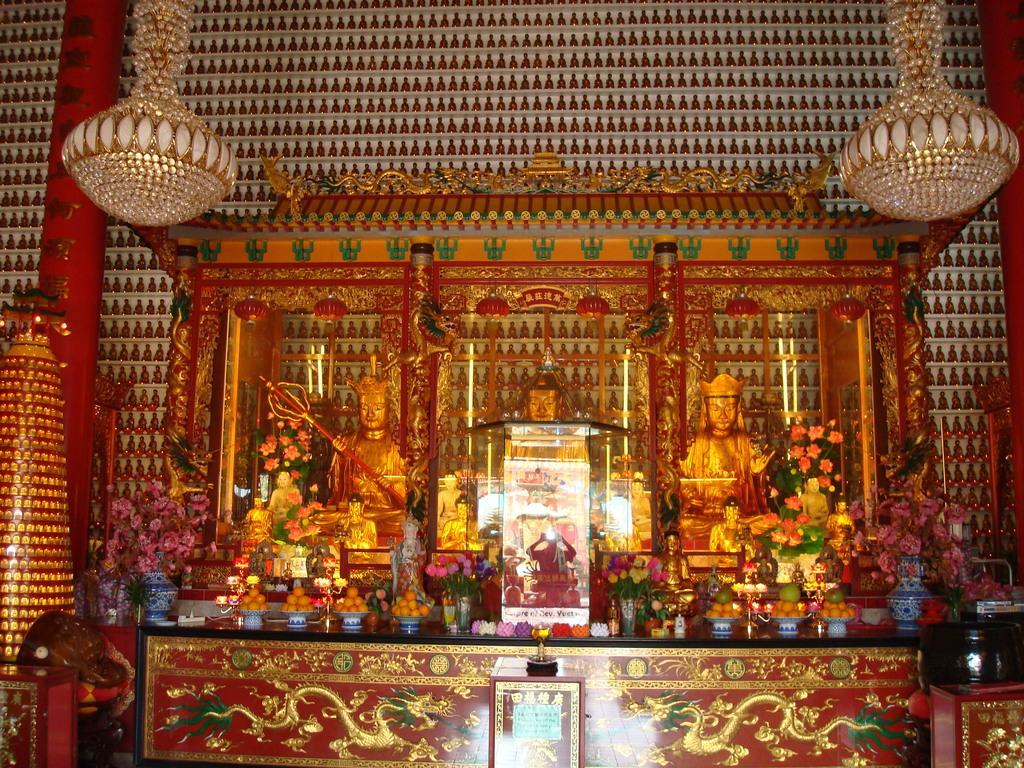How would you summarize this image in a sentence or two? In this image on a dais there are statues, flower pots, food on plates, candles are there. On the top there are chandeliers. The wall is decorated. 